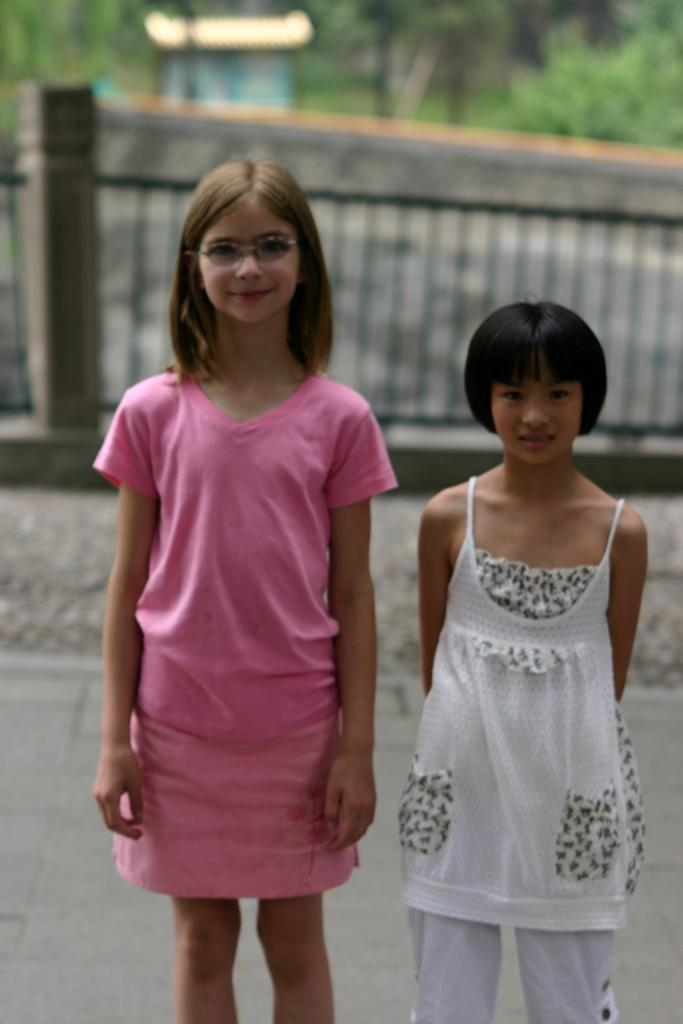Who is present in the image? There are girls in the image. What are the girls doing in the image? The girls are standing and smiling. Can you describe the background of the image? The background of the image is blurry. What type of building can be seen in the background of the image? There is no building visible in the background of the image; it is blurry. 